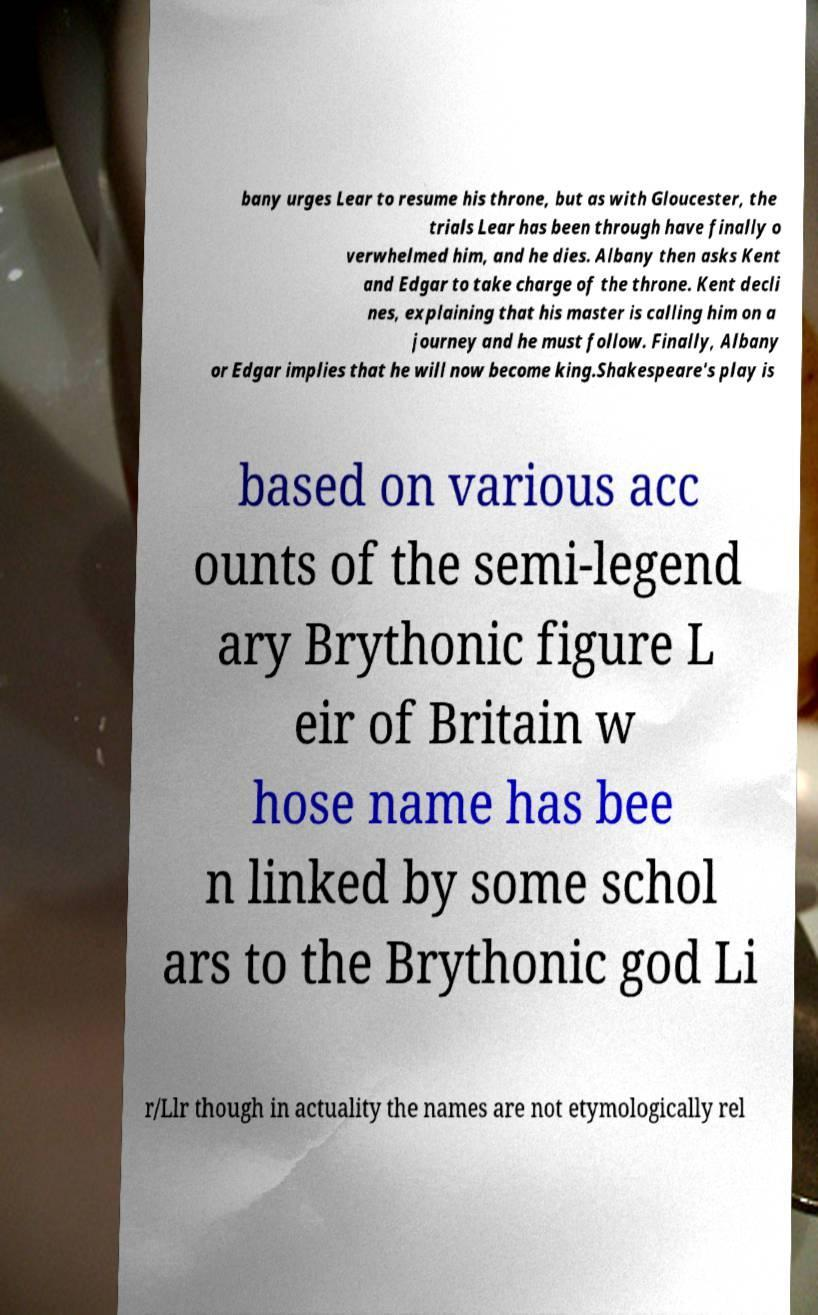Please read and relay the text visible in this image. What does it say? bany urges Lear to resume his throne, but as with Gloucester, the trials Lear has been through have finally o verwhelmed him, and he dies. Albany then asks Kent and Edgar to take charge of the throne. Kent decli nes, explaining that his master is calling him on a journey and he must follow. Finally, Albany or Edgar implies that he will now become king.Shakespeare's play is based on various acc ounts of the semi-legend ary Brythonic figure L eir of Britain w hose name has bee n linked by some schol ars to the Brythonic god Li r/Llr though in actuality the names are not etymologically rel 